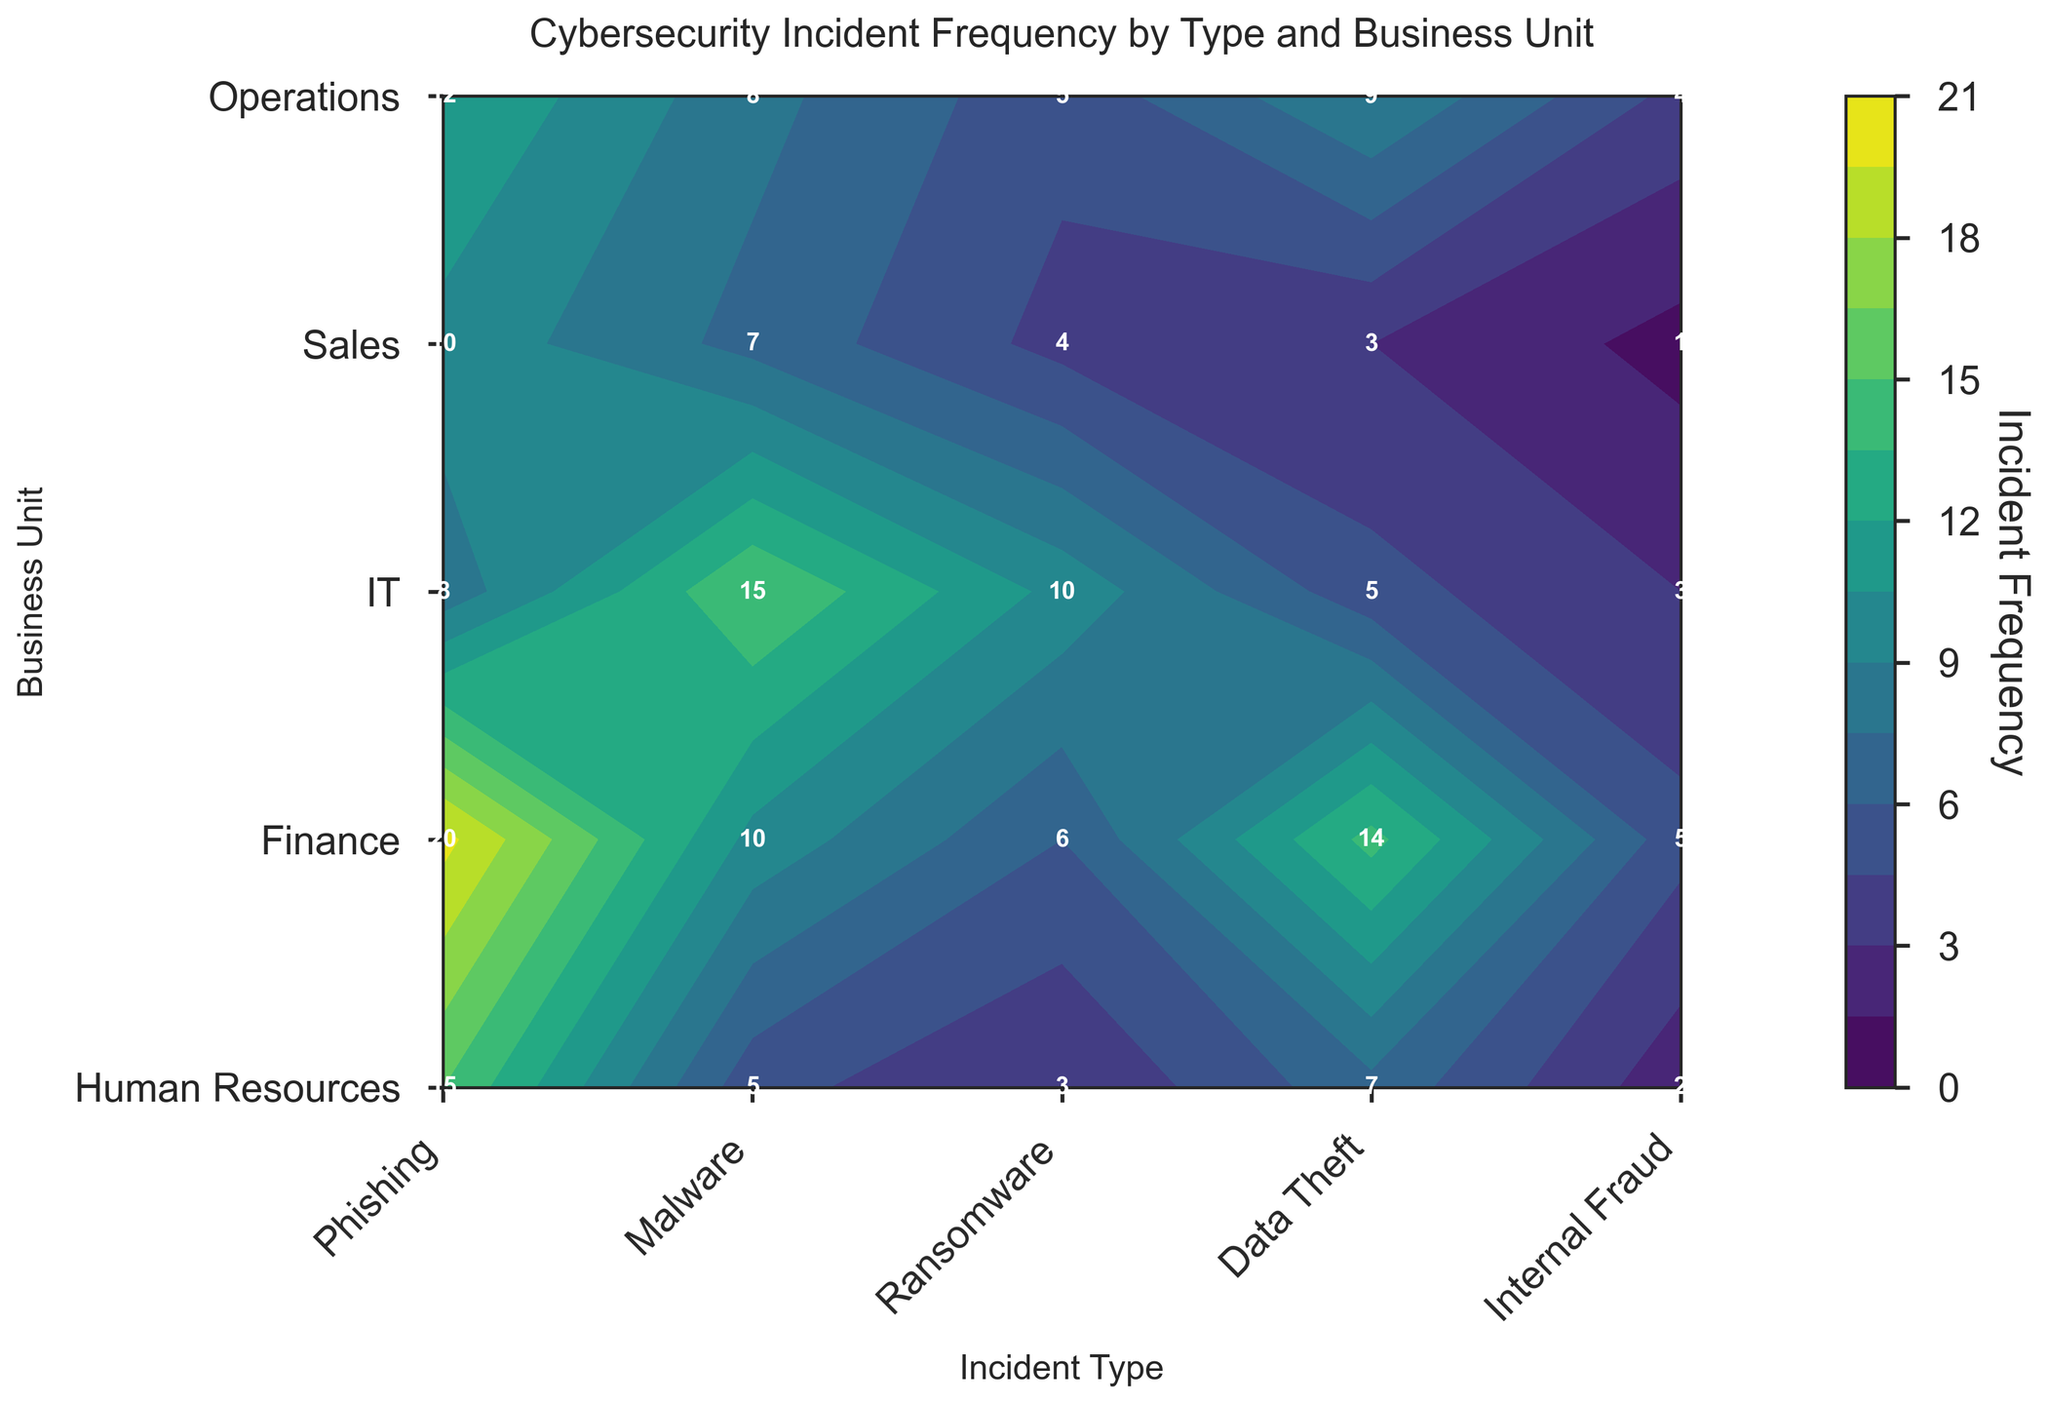What's the title of the plot? The title of the plot is usually displayed at the top of the figure, and it describes the main topic being visualized.
Answer: Cybersecurity Incident Frequency by Type and Business Unit Which business unit experienced the highest frequency of phishing incidents? Check the Phishing column in the contour plot and look for the business unit with the darkest color or highest value.
Answer: Finance Which business unit had the lowest occurrence of internal fraud? Look at the Internal Fraud column and find the business unit with the lightest color or smallest value.
Answer: Sales What is the total number of ransomware incidents across all business units? Sum the numbers in the Ransomware column to get the total incidents: 3 (Human Resources) + 6 (Finance) + 10 (IT) + 4 (Sales) + 5 (Operations).
Answer: 28 Which incident type has the highest overall frequency in the Human Resources unit? Identify which cell in the Human Resources row has the darkest color or highest value. Compare each incident type value.
Answer: Phishing Compare the frequency of malware incidents between IT and Finance. Which has more? Look at the Malware column and compare the values for IT (15) and Finance (10).
Answer: IT What is the average number of data theft incidents across all business units? Add the Data Theft values for all units and divide by the number of business units: (7 + 14 + 5 + 3 + 9) / 5.
Answer: 7.6 How many total incidents did the Sales unit experience? Sum up all incident types for Sales: 10 (Phishing) + 7 (Malware) + 4 (Ransomware) + 3 (Data Theft) + 1 (Internal Fraud).
Answer: 25 Which business unit has the highest variance in incident types? Compare the variance within each row by looking for the most diverse set of dark and light colors indicating a wide range among values. Calculate variances if needed.
Answer: Finance Is there any business unit where the phishing incidents are less than the data theft incidents? Compare the columns of Phishing and Data Theft for each business unit to see if any business unit has a smaller value in Phishing than in Data Theft.
Answer: No 